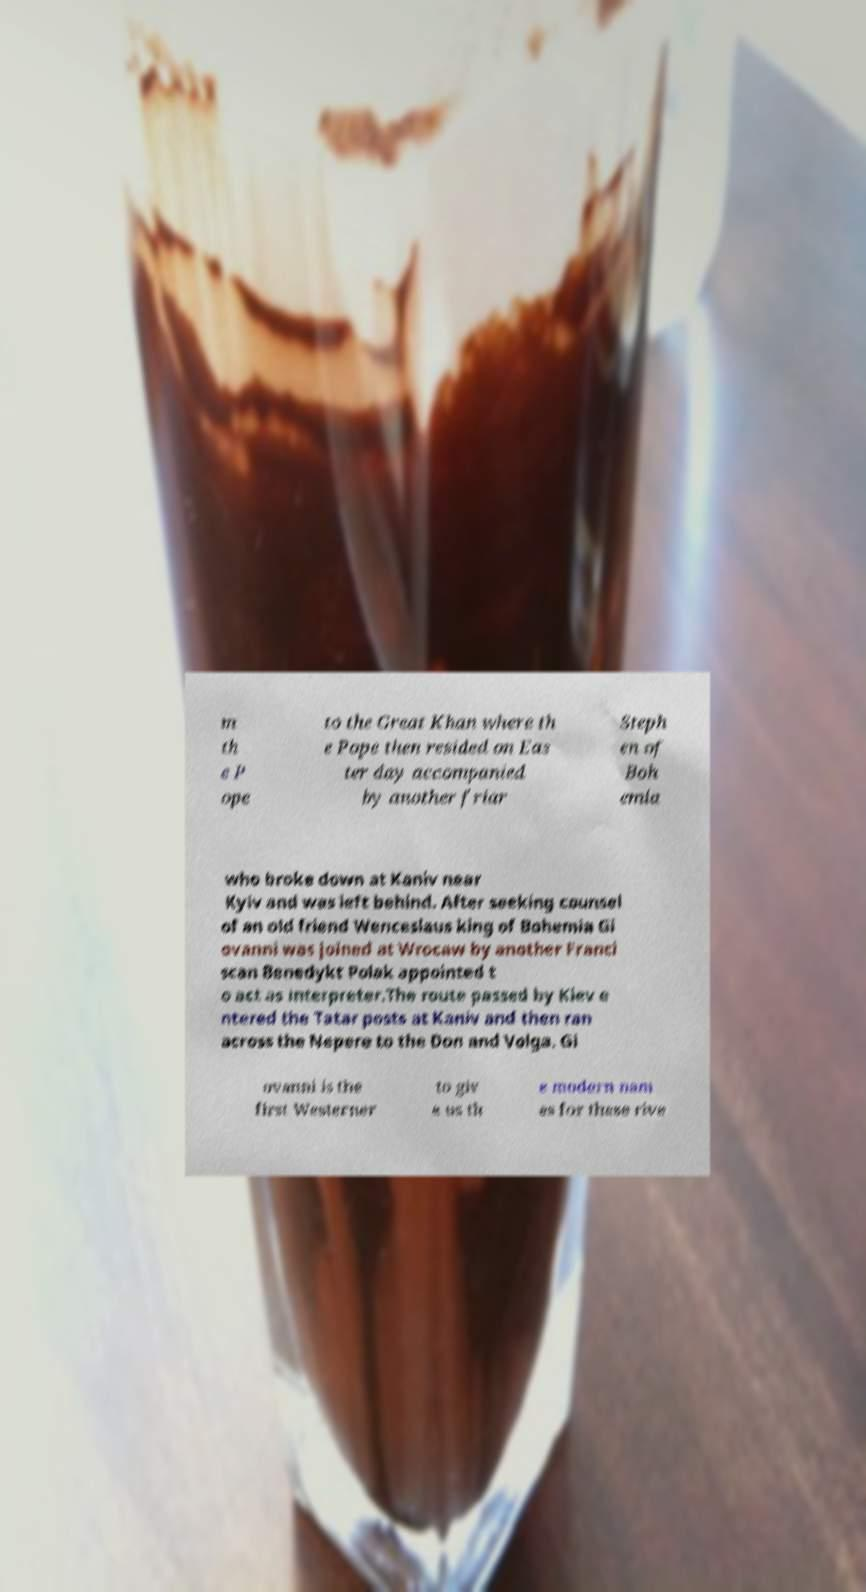There's text embedded in this image that I need extracted. Can you transcribe it verbatim? m th e P ope to the Great Khan where th e Pope then resided on Eas ter day accompanied by another friar Steph en of Boh emia who broke down at Kaniv near Kyiv and was left behind. After seeking counsel of an old friend Wenceslaus king of Bohemia Gi ovanni was joined at Wrocaw by another Franci scan Benedykt Polak appointed t o act as interpreter.The route passed by Kiev e ntered the Tatar posts at Kaniv and then ran across the Nepere to the Don and Volga. Gi ovanni is the first Westerner to giv e us th e modern nam es for these rive 